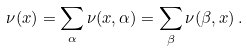Convert formula to latex. <formula><loc_0><loc_0><loc_500><loc_500>\nu ( x ) = \sum _ { \alpha } \nu ( x , \alpha ) = \sum _ { \beta } \nu ( \beta , x ) \, .</formula> 